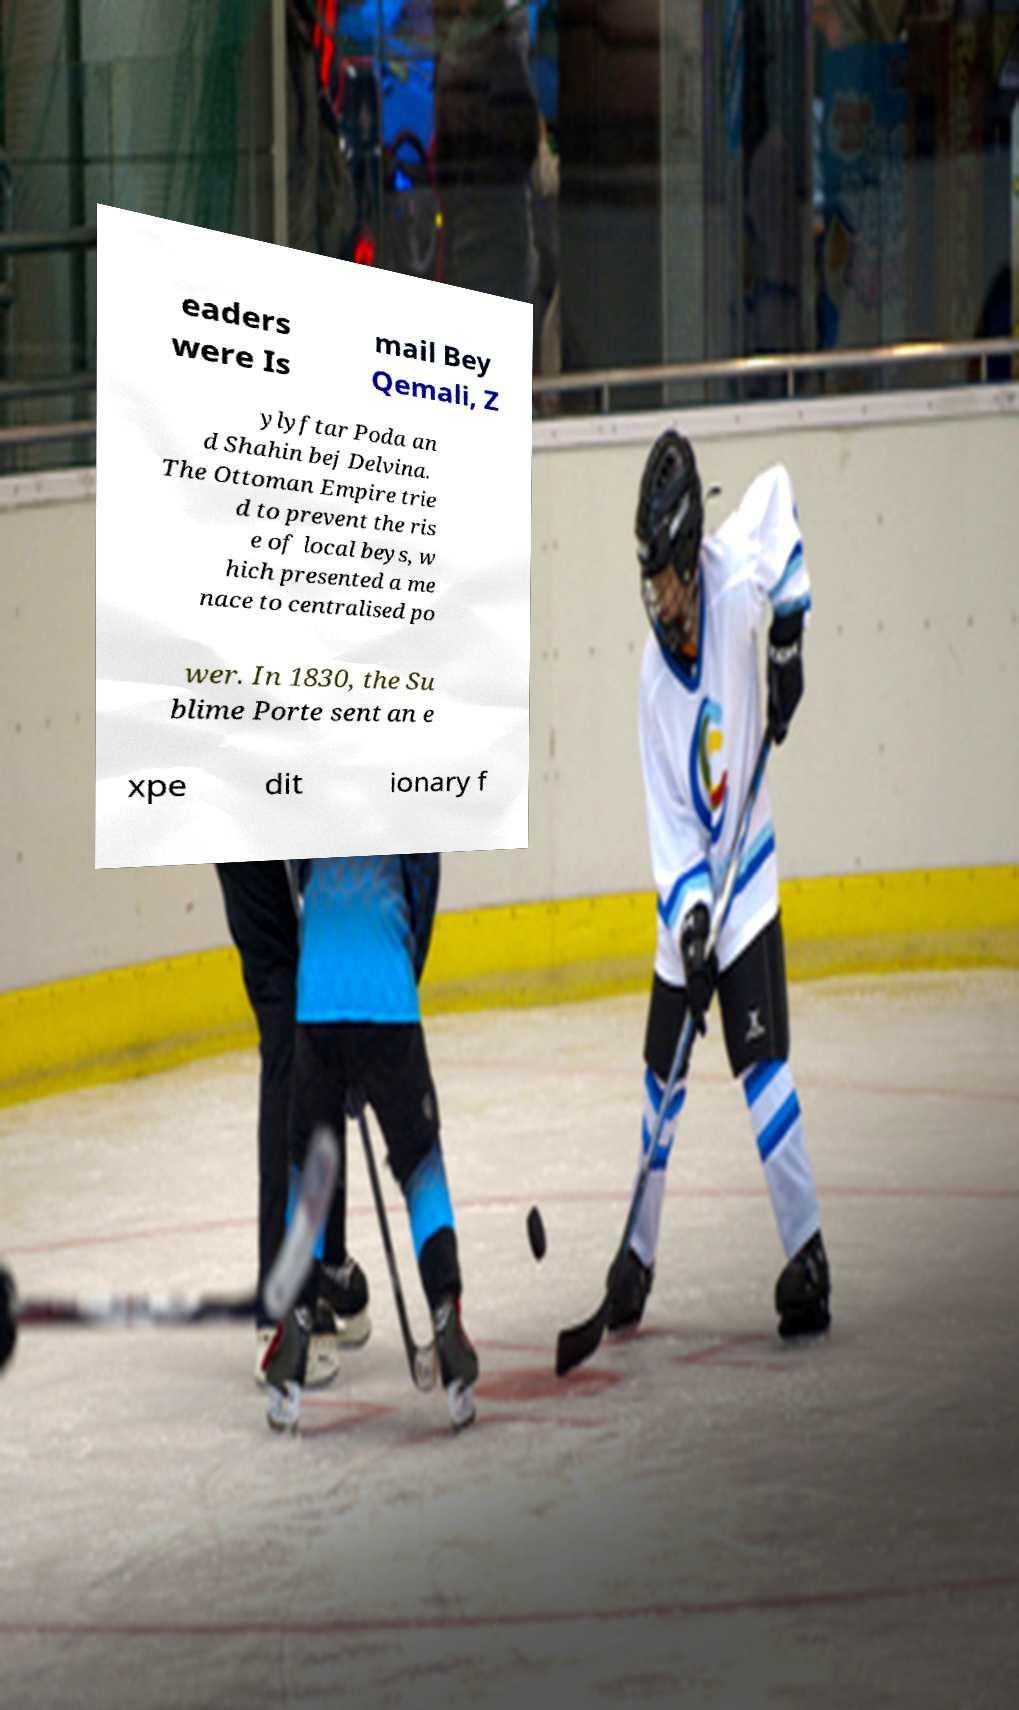Please read and relay the text visible in this image. What does it say? eaders were Is mail Bey Qemali, Z ylyftar Poda an d Shahin bej Delvina. The Ottoman Empire trie d to prevent the ris e of local beys, w hich presented a me nace to centralised po wer. In 1830, the Su blime Porte sent an e xpe dit ionary f 